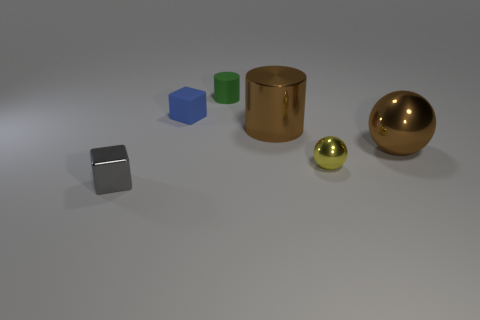Add 2 small shiny spheres. How many objects exist? 8 Subtract 1 cubes. How many cubes are left? 1 Subtract all blocks. How many objects are left? 4 Subtract 1 brown cylinders. How many objects are left? 5 Subtract all yellow cubes. Subtract all red cylinders. How many cubes are left? 2 Subtract all small green matte things. Subtract all brown objects. How many objects are left? 3 Add 4 small blocks. How many small blocks are left? 6 Add 2 tiny shiny things. How many tiny shiny things exist? 4 